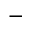Convert formula to latex. <formula><loc_0><loc_0><loc_500><loc_500>^ { - }</formula> 